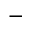Convert formula to latex. <formula><loc_0><loc_0><loc_500><loc_500>^ { - }</formula> 